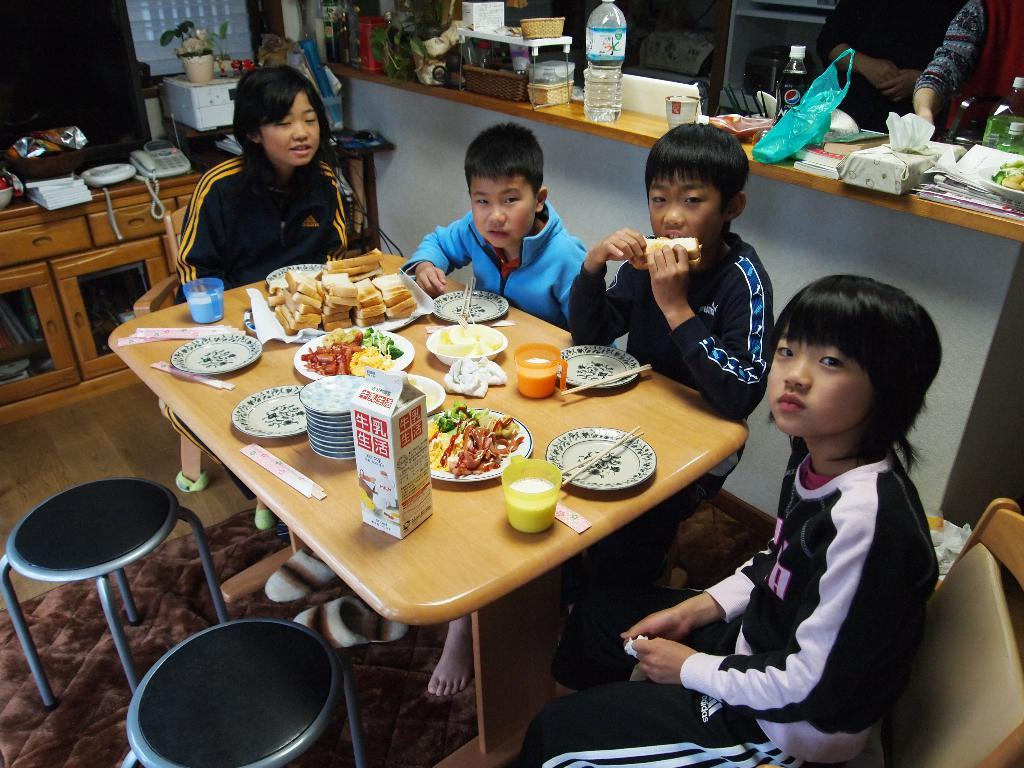What are the people in the image doing? There is a group of people seated in the image. What type of furniture is present in the image? There are chairs in the image. What can be found on the table in the image? There are plates, food, water bottles, and phones on the table in the image. What type of bean is growing in the garden in the image? There is no garden or bean present in the image. What type of furniture is missing from the image? There is no information about missing furniture in the image. 